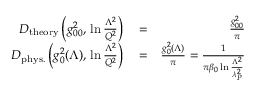Convert formula to latex. <formula><loc_0><loc_0><loc_500><loc_500>\begin{array} { r l r } { D _ { t h e o r y } \left ( g _ { 0 0 } ^ { 2 } , \, \ln { \frac { \Lambda ^ { 2 } } { Q ^ { 2 } } } \right ) } & = } & { { \frac { g _ { 0 0 } ^ { 2 } } { \pi } } } \\ { D _ { p h y s . } \left ( g _ { 0 } ^ { 2 } ( \Lambda ) , \, \ln { \frac { \Lambda ^ { 2 } } { Q ^ { 2 } } } \right ) } & = } & { { \frac { g _ { 0 } ^ { 2 } ( \Lambda ) } { \pi } } = { \frac { 1 } { \pi \beta _ { 0 } \ln { \frac { \Lambda ^ { 2 } } { \lambda _ { P } ^ { 2 } } } } } } \end{array}</formula> 